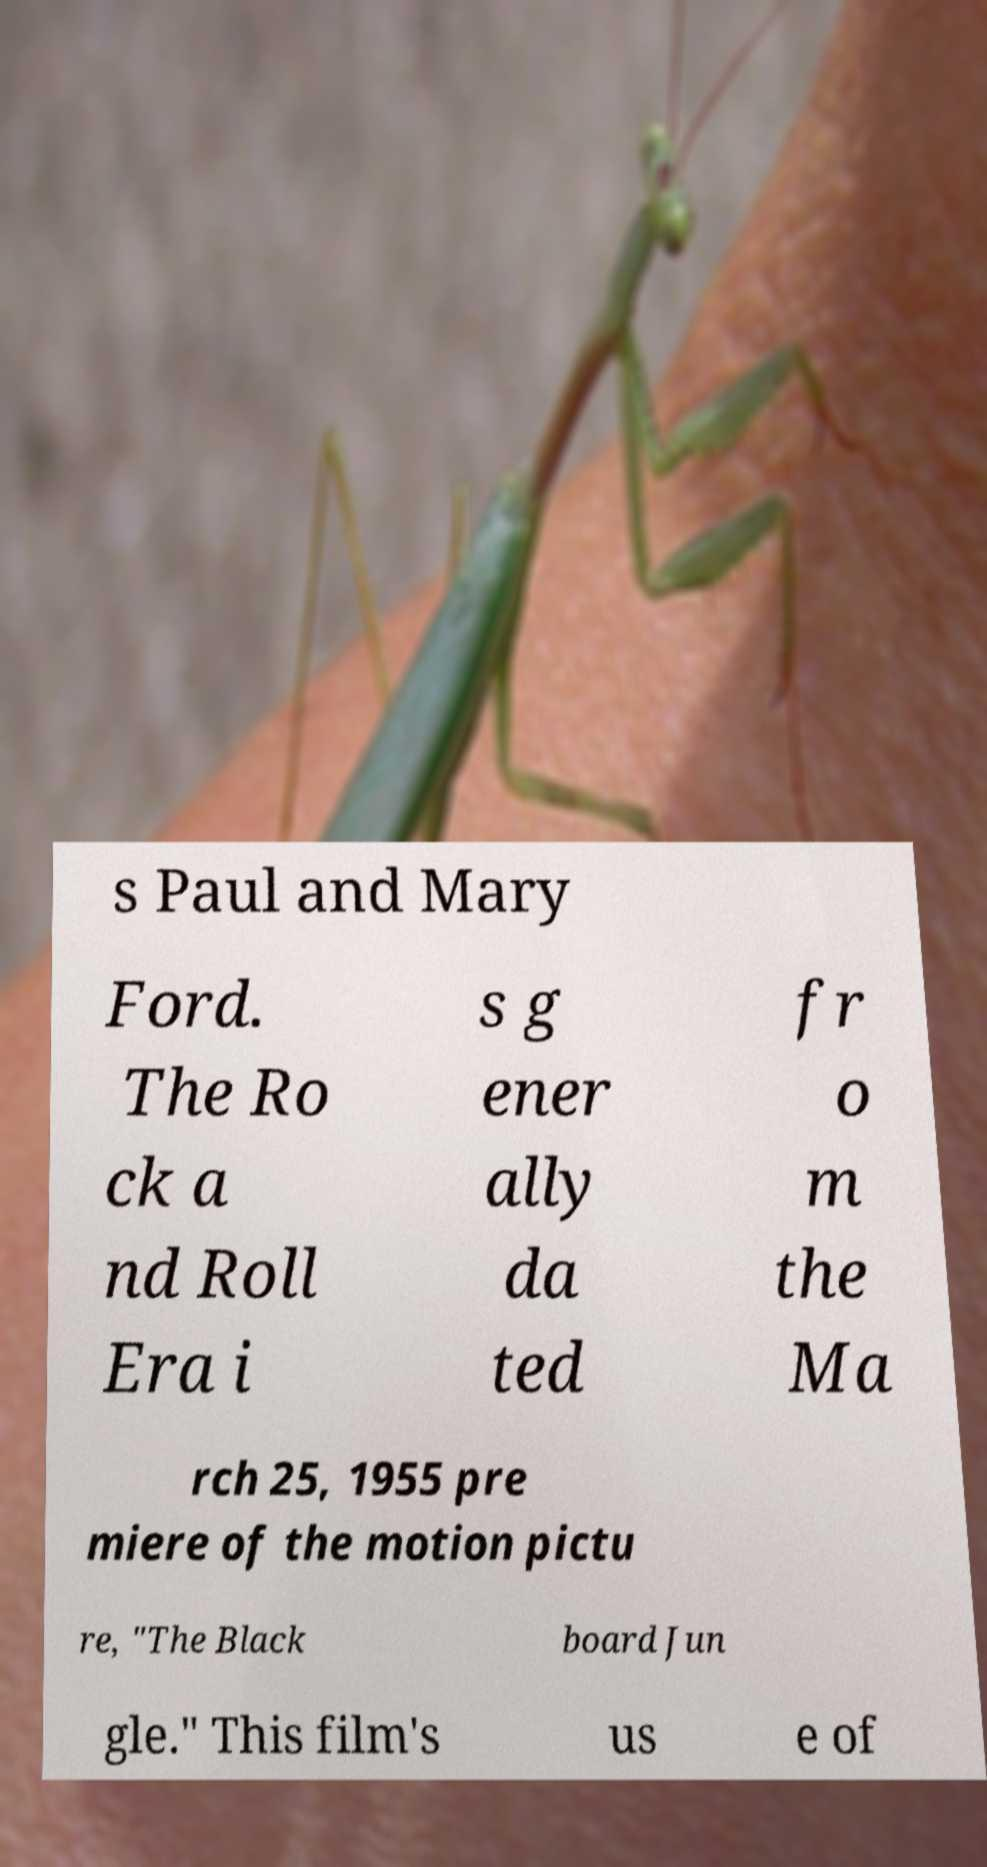I need the written content from this picture converted into text. Can you do that? s Paul and Mary Ford. The Ro ck a nd Roll Era i s g ener ally da ted fr o m the Ma rch 25, 1955 pre miere of the motion pictu re, "The Black board Jun gle." This film's us e of 